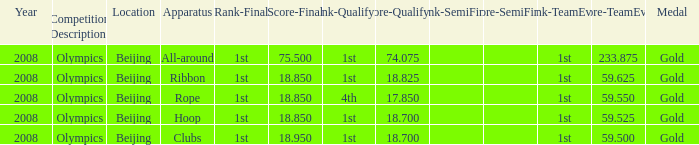On which apparatus did Kanayeva have a final score smaller than 75.5 and a qualifying score smaller than 18.7? Rope. 